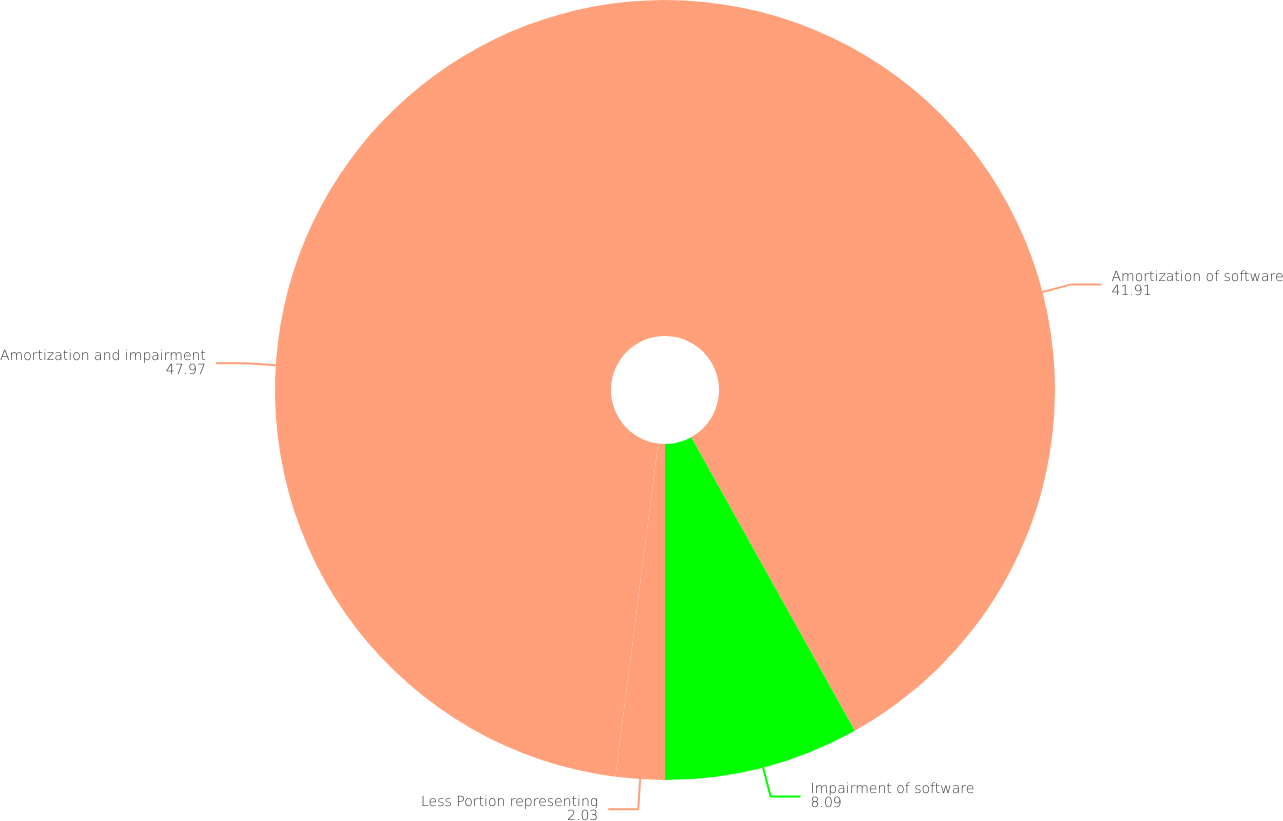Convert chart. <chart><loc_0><loc_0><loc_500><loc_500><pie_chart><fcel>Amortization of software<fcel>Impairment of software<fcel>Less Portion representing<fcel>Amortization and impairment<nl><fcel>41.91%<fcel>8.09%<fcel>2.03%<fcel>47.97%<nl></chart> 